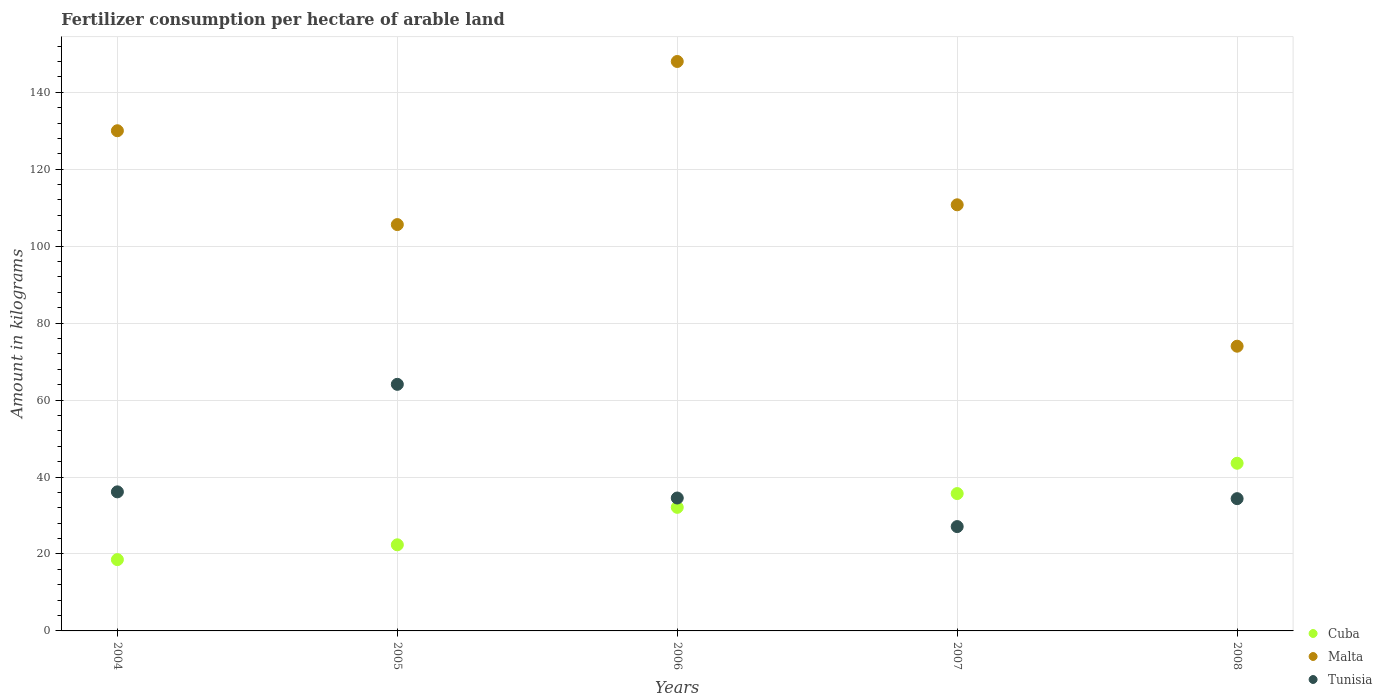How many different coloured dotlines are there?
Keep it short and to the point. 3. What is the amount of fertilizer consumption in Cuba in 2008?
Provide a short and direct response. 43.58. Across all years, what is the maximum amount of fertilizer consumption in Malta?
Make the answer very short. 148. Across all years, what is the minimum amount of fertilizer consumption in Cuba?
Offer a terse response. 18.53. In which year was the amount of fertilizer consumption in Malta maximum?
Offer a very short reply. 2006. In which year was the amount of fertilizer consumption in Malta minimum?
Ensure brevity in your answer.  2008. What is the total amount of fertilizer consumption in Tunisia in the graph?
Offer a very short reply. 196.27. What is the difference between the amount of fertilizer consumption in Cuba in 2006 and that in 2008?
Ensure brevity in your answer.  -11.46. What is the difference between the amount of fertilizer consumption in Cuba in 2006 and the amount of fertilizer consumption in Tunisia in 2004?
Make the answer very short. -4.02. What is the average amount of fertilizer consumption in Cuba per year?
Make the answer very short. 30.46. In the year 2006, what is the difference between the amount of fertilizer consumption in Tunisia and amount of fertilizer consumption in Malta?
Provide a short and direct response. -113.46. In how many years, is the amount of fertilizer consumption in Malta greater than 80 kg?
Give a very brief answer. 4. What is the ratio of the amount of fertilizer consumption in Tunisia in 2006 to that in 2008?
Provide a short and direct response. 1. What is the difference between the highest and the second highest amount of fertilizer consumption in Tunisia?
Give a very brief answer. 27.95. What is the difference between the highest and the lowest amount of fertilizer consumption in Cuba?
Provide a succinct answer. 25.05. In how many years, is the amount of fertilizer consumption in Malta greater than the average amount of fertilizer consumption in Malta taken over all years?
Give a very brief answer. 2. Is the sum of the amount of fertilizer consumption in Tunisia in 2005 and 2008 greater than the maximum amount of fertilizer consumption in Malta across all years?
Make the answer very short. No. Is it the case that in every year, the sum of the amount of fertilizer consumption in Tunisia and amount of fertilizer consumption in Malta  is greater than the amount of fertilizer consumption in Cuba?
Your answer should be compact. Yes. Does the amount of fertilizer consumption in Malta monotonically increase over the years?
Offer a terse response. No. How many dotlines are there?
Give a very brief answer. 3. Does the graph contain any zero values?
Give a very brief answer. No. Does the graph contain grids?
Your answer should be compact. Yes. How many legend labels are there?
Provide a short and direct response. 3. What is the title of the graph?
Your response must be concise. Fertilizer consumption per hectare of arable land. What is the label or title of the X-axis?
Make the answer very short. Years. What is the label or title of the Y-axis?
Offer a terse response. Amount in kilograms. What is the Amount in kilograms of Cuba in 2004?
Give a very brief answer. 18.53. What is the Amount in kilograms of Malta in 2004?
Your answer should be compact. 130. What is the Amount in kilograms of Tunisia in 2004?
Keep it short and to the point. 36.14. What is the Amount in kilograms in Cuba in 2005?
Ensure brevity in your answer.  22.38. What is the Amount in kilograms in Malta in 2005?
Your answer should be very brief. 105.61. What is the Amount in kilograms in Tunisia in 2005?
Offer a terse response. 64.09. What is the Amount in kilograms of Cuba in 2006?
Give a very brief answer. 32.12. What is the Amount in kilograms in Malta in 2006?
Offer a terse response. 148. What is the Amount in kilograms of Tunisia in 2006?
Offer a very short reply. 34.54. What is the Amount in kilograms of Cuba in 2007?
Your answer should be very brief. 35.7. What is the Amount in kilograms of Malta in 2007?
Ensure brevity in your answer.  110.75. What is the Amount in kilograms of Tunisia in 2007?
Give a very brief answer. 27.12. What is the Amount in kilograms of Cuba in 2008?
Give a very brief answer. 43.58. What is the Amount in kilograms in Tunisia in 2008?
Give a very brief answer. 34.38. Across all years, what is the maximum Amount in kilograms of Cuba?
Your response must be concise. 43.58. Across all years, what is the maximum Amount in kilograms of Malta?
Give a very brief answer. 148. Across all years, what is the maximum Amount in kilograms in Tunisia?
Your response must be concise. 64.09. Across all years, what is the minimum Amount in kilograms in Cuba?
Offer a very short reply. 18.53. Across all years, what is the minimum Amount in kilograms in Malta?
Offer a very short reply. 74. Across all years, what is the minimum Amount in kilograms of Tunisia?
Your answer should be compact. 27.12. What is the total Amount in kilograms of Cuba in the graph?
Offer a terse response. 152.31. What is the total Amount in kilograms in Malta in the graph?
Give a very brief answer. 568.36. What is the total Amount in kilograms in Tunisia in the graph?
Make the answer very short. 196.27. What is the difference between the Amount in kilograms of Cuba in 2004 and that in 2005?
Keep it short and to the point. -3.85. What is the difference between the Amount in kilograms of Malta in 2004 and that in 2005?
Keep it short and to the point. 24.39. What is the difference between the Amount in kilograms in Tunisia in 2004 and that in 2005?
Make the answer very short. -27.95. What is the difference between the Amount in kilograms of Cuba in 2004 and that in 2006?
Your answer should be compact. -13.59. What is the difference between the Amount in kilograms of Tunisia in 2004 and that in 2006?
Offer a terse response. 1.6. What is the difference between the Amount in kilograms in Cuba in 2004 and that in 2007?
Your answer should be very brief. -17.17. What is the difference between the Amount in kilograms in Malta in 2004 and that in 2007?
Your response must be concise. 19.25. What is the difference between the Amount in kilograms in Tunisia in 2004 and that in 2007?
Offer a very short reply. 9.03. What is the difference between the Amount in kilograms in Cuba in 2004 and that in 2008?
Offer a very short reply. -25.05. What is the difference between the Amount in kilograms of Tunisia in 2004 and that in 2008?
Provide a succinct answer. 1.77. What is the difference between the Amount in kilograms of Cuba in 2005 and that in 2006?
Ensure brevity in your answer.  -9.74. What is the difference between the Amount in kilograms of Malta in 2005 and that in 2006?
Ensure brevity in your answer.  -42.39. What is the difference between the Amount in kilograms in Tunisia in 2005 and that in 2006?
Provide a short and direct response. 29.55. What is the difference between the Amount in kilograms of Cuba in 2005 and that in 2007?
Keep it short and to the point. -13.32. What is the difference between the Amount in kilograms of Malta in 2005 and that in 2007?
Make the answer very short. -5.14. What is the difference between the Amount in kilograms in Tunisia in 2005 and that in 2007?
Keep it short and to the point. 36.97. What is the difference between the Amount in kilograms of Cuba in 2005 and that in 2008?
Make the answer very short. -21.2. What is the difference between the Amount in kilograms in Malta in 2005 and that in 2008?
Your response must be concise. 31.61. What is the difference between the Amount in kilograms of Tunisia in 2005 and that in 2008?
Provide a short and direct response. 29.71. What is the difference between the Amount in kilograms in Cuba in 2006 and that in 2007?
Provide a succinct answer. -3.58. What is the difference between the Amount in kilograms of Malta in 2006 and that in 2007?
Your response must be concise. 37.25. What is the difference between the Amount in kilograms in Tunisia in 2006 and that in 2007?
Provide a succinct answer. 7.43. What is the difference between the Amount in kilograms of Cuba in 2006 and that in 2008?
Provide a succinct answer. -11.46. What is the difference between the Amount in kilograms in Tunisia in 2006 and that in 2008?
Offer a terse response. 0.17. What is the difference between the Amount in kilograms of Cuba in 2007 and that in 2008?
Make the answer very short. -7.88. What is the difference between the Amount in kilograms in Malta in 2007 and that in 2008?
Your answer should be compact. 36.75. What is the difference between the Amount in kilograms of Tunisia in 2007 and that in 2008?
Give a very brief answer. -7.26. What is the difference between the Amount in kilograms in Cuba in 2004 and the Amount in kilograms in Malta in 2005?
Make the answer very short. -87.08. What is the difference between the Amount in kilograms in Cuba in 2004 and the Amount in kilograms in Tunisia in 2005?
Offer a very short reply. -45.56. What is the difference between the Amount in kilograms of Malta in 2004 and the Amount in kilograms of Tunisia in 2005?
Your answer should be very brief. 65.91. What is the difference between the Amount in kilograms of Cuba in 2004 and the Amount in kilograms of Malta in 2006?
Provide a succinct answer. -129.47. What is the difference between the Amount in kilograms in Cuba in 2004 and the Amount in kilograms in Tunisia in 2006?
Make the answer very short. -16.01. What is the difference between the Amount in kilograms in Malta in 2004 and the Amount in kilograms in Tunisia in 2006?
Provide a short and direct response. 95.46. What is the difference between the Amount in kilograms in Cuba in 2004 and the Amount in kilograms in Malta in 2007?
Provide a succinct answer. -92.22. What is the difference between the Amount in kilograms in Cuba in 2004 and the Amount in kilograms in Tunisia in 2007?
Provide a short and direct response. -8.59. What is the difference between the Amount in kilograms of Malta in 2004 and the Amount in kilograms of Tunisia in 2007?
Ensure brevity in your answer.  102.88. What is the difference between the Amount in kilograms of Cuba in 2004 and the Amount in kilograms of Malta in 2008?
Make the answer very short. -55.47. What is the difference between the Amount in kilograms in Cuba in 2004 and the Amount in kilograms in Tunisia in 2008?
Your response must be concise. -15.85. What is the difference between the Amount in kilograms of Malta in 2004 and the Amount in kilograms of Tunisia in 2008?
Your response must be concise. 95.62. What is the difference between the Amount in kilograms of Cuba in 2005 and the Amount in kilograms of Malta in 2006?
Your answer should be compact. -125.62. What is the difference between the Amount in kilograms of Cuba in 2005 and the Amount in kilograms of Tunisia in 2006?
Ensure brevity in your answer.  -12.16. What is the difference between the Amount in kilograms of Malta in 2005 and the Amount in kilograms of Tunisia in 2006?
Give a very brief answer. 71.07. What is the difference between the Amount in kilograms in Cuba in 2005 and the Amount in kilograms in Malta in 2007?
Offer a terse response. -88.37. What is the difference between the Amount in kilograms of Cuba in 2005 and the Amount in kilograms of Tunisia in 2007?
Give a very brief answer. -4.74. What is the difference between the Amount in kilograms in Malta in 2005 and the Amount in kilograms in Tunisia in 2007?
Give a very brief answer. 78.49. What is the difference between the Amount in kilograms of Cuba in 2005 and the Amount in kilograms of Malta in 2008?
Your answer should be compact. -51.62. What is the difference between the Amount in kilograms of Cuba in 2005 and the Amount in kilograms of Tunisia in 2008?
Give a very brief answer. -12. What is the difference between the Amount in kilograms in Malta in 2005 and the Amount in kilograms in Tunisia in 2008?
Your answer should be very brief. 71.23. What is the difference between the Amount in kilograms in Cuba in 2006 and the Amount in kilograms in Malta in 2007?
Provide a short and direct response. -78.63. What is the difference between the Amount in kilograms of Cuba in 2006 and the Amount in kilograms of Tunisia in 2007?
Give a very brief answer. 5. What is the difference between the Amount in kilograms in Malta in 2006 and the Amount in kilograms in Tunisia in 2007?
Provide a succinct answer. 120.88. What is the difference between the Amount in kilograms in Cuba in 2006 and the Amount in kilograms in Malta in 2008?
Provide a succinct answer. -41.88. What is the difference between the Amount in kilograms of Cuba in 2006 and the Amount in kilograms of Tunisia in 2008?
Provide a succinct answer. -2.26. What is the difference between the Amount in kilograms in Malta in 2006 and the Amount in kilograms in Tunisia in 2008?
Give a very brief answer. 113.62. What is the difference between the Amount in kilograms in Cuba in 2007 and the Amount in kilograms in Malta in 2008?
Ensure brevity in your answer.  -38.3. What is the difference between the Amount in kilograms of Cuba in 2007 and the Amount in kilograms of Tunisia in 2008?
Your answer should be very brief. 1.32. What is the difference between the Amount in kilograms of Malta in 2007 and the Amount in kilograms of Tunisia in 2008?
Offer a terse response. 76.37. What is the average Amount in kilograms of Cuba per year?
Your response must be concise. 30.46. What is the average Amount in kilograms of Malta per year?
Keep it short and to the point. 113.67. What is the average Amount in kilograms of Tunisia per year?
Offer a terse response. 39.25. In the year 2004, what is the difference between the Amount in kilograms in Cuba and Amount in kilograms in Malta?
Your answer should be compact. -111.47. In the year 2004, what is the difference between the Amount in kilograms of Cuba and Amount in kilograms of Tunisia?
Provide a short and direct response. -17.61. In the year 2004, what is the difference between the Amount in kilograms of Malta and Amount in kilograms of Tunisia?
Your answer should be compact. 93.86. In the year 2005, what is the difference between the Amount in kilograms of Cuba and Amount in kilograms of Malta?
Provide a succinct answer. -83.23. In the year 2005, what is the difference between the Amount in kilograms in Cuba and Amount in kilograms in Tunisia?
Offer a very short reply. -41.71. In the year 2005, what is the difference between the Amount in kilograms in Malta and Amount in kilograms in Tunisia?
Keep it short and to the point. 41.52. In the year 2006, what is the difference between the Amount in kilograms in Cuba and Amount in kilograms in Malta?
Your response must be concise. -115.88. In the year 2006, what is the difference between the Amount in kilograms of Cuba and Amount in kilograms of Tunisia?
Offer a very short reply. -2.42. In the year 2006, what is the difference between the Amount in kilograms in Malta and Amount in kilograms in Tunisia?
Give a very brief answer. 113.46. In the year 2007, what is the difference between the Amount in kilograms of Cuba and Amount in kilograms of Malta?
Offer a terse response. -75.05. In the year 2007, what is the difference between the Amount in kilograms of Cuba and Amount in kilograms of Tunisia?
Make the answer very short. 8.58. In the year 2007, what is the difference between the Amount in kilograms of Malta and Amount in kilograms of Tunisia?
Offer a very short reply. 83.63. In the year 2008, what is the difference between the Amount in kilograms of Cuba and Amount in kilograms of Malta?
Offer a terse response. -30.42. In the year 2008, what is the difference between the Amount in kilograms in Cuba and Amount in kilograms in Tunisia?
Give a very brief answer. 9.2. In the year 2008, what is the difference between the Amount in kilograms of Malta and Amount in kilograms of Tunisia?
Ensure brevity in your answer.  39.62. What is the ratio of the Amount in kilograms of Cuba in 2004 to that in 2005?
Your answer should be compact. 0.83. What is the ratio of the Amount in kilograms in Malta in 2004 to that in 2005?
Provide a succinct answer. 1.23. What is the ratio of the Amount in kilograms of Tunisia in 2004 to that in 2005?
Offer a very short reply. 0.56. What is the ratio of the Amount in kilograms in Cuba in 2004 to that in 2006?
Provide a succinct answer. 0.58. What is the ratio of the Amount in kilograms of Malta in 2004 to that in 2006?
Make the answer very short. 0.88. What is the ratio of the Amount in kilograms of Tunisia in 2004 to that in 2006?
Your response must be concise. 1.05. What is the ratio of the Amount in kilograms in Cuba in 2004 to that in 2007?
Ensure brevity in your answer.  0.52. What is the ratio of the Amount in kilograms of Malta in 2004 to that in 2007?
Keep it short and to the point. 1.17. What is the ratio of the Amount in kilograms in Tunisia in 2004 to that in 2007?
Your response must be concise. 1.33. What is the ratio of the Amount in kilograms of Cuba in 2004 to that in 2008?
Ensure brevity in your answer.  0.43. What is the ratio of the Amount in kilograms of Malta in 2004 to that in 2008?
Offer a terse response. 1.76. What is the ratio of the Amount in kilograms of Tunisia in 2004 to that in 2008?
Provide a short and direct response. 1.05. What is the ratio of the Amount in kilograms of Cuba in 2005 to that in 2006?
Provide a succinct answer. 0.7. What is the ratio of the Amount in kilograms of Malta in 2005 to that in 2006?
Keep it short and to the point. 0.71. What is the ratio of the Amount in kilograms in Tunisia in 2005 to that in 2006?
Give a very brief answer. 1.86. What is the ratio of the Amount in kilograms of Cuba in 2005 to that in 2007?
Ensure brevity in your answer.  0.63. What is the ratio of the Amount in kilograms of Malta in 2005 to that in 2007?
Make the answer very short. 0.95. What is the ratio of the Amount in kilograms of Tunisia in 2005 to that in 2007?
Keep it short and to the point. 2.36. What is the ratio of the Amount in kilograms in Cuba in 2005 to that in 2008?
Ensure brevity in your answer.  0.51. What is the ratio of the Amount in kilograms of Malta in 2005 to that in 2008?
Your answer should be very brief. 1.43. What is the ratio of the Amount in kilograms of Tunisia in 2005 to that in 2008?
Your response must be concise. 1.86. What is the ratio of the Amount in kilograms in Cuba in 2006 to that in 2007?
Ensure brevity in your answer.  0.9. What is the ratio of the Amount in kilograms of Malta in 2006 to that in 2007?
Offer a very short reply. 1.34. What is the ratio of the Amount in kilograms in Tunisia in 2006 to that in 2007?
Give a very brief answer. 1.27. What is the ratio of the Amount in kilograms in Cuba in 2006 to that in 2008?
Offer a very short reply. 0.74. What is the ratio of the Amount in kilograms in Malta in 2006 to that in 2008?
Make the answer very short. 2. What is the ratio of the Amount in kilograms in Tunisia in 2006 to that in 2008?
Offer a terse response. 1. What is the ratio of the Amount in kilograms in Cuba in 2007 to that in 2008?
Offer a very short reply. 0.82. What is the ratio of the Amount in kilograms of Malta in 2007 to that in 2008?
Provide a succinct answer. 1.5. What is the ratio of the Amount in kilograms in Tunisia in 2007 to that in 2008?
Your response must be concise. 0.79. What is the difference between the highest and the second highest Amount in kilograms of Cuba?
Ensure brevity in your answer.  7.88. What is the difference between the highest and the second highest Amount in kilograms in Malta?
Provide a succinct answer. 18. What is the difference between the highest and the second highest Amount in kilograms of Tunisia?
Your answer should be compact. 27.95. What is the difference between the highest and the lowest Amount in kilograms of Cuba?
Give a very brief answer. 25.05. What is the difference between the highest and the lowest Amount in kilograms of Tunisia?
Provide a succinct answer. 36.97. 